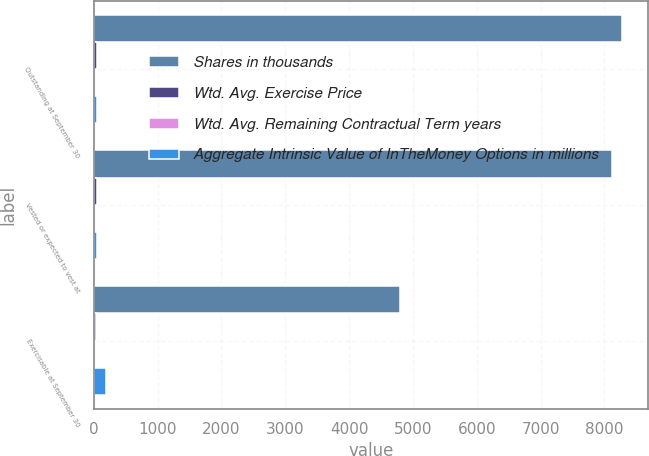<chart> <loc_0><loc_0><loc_500><loc_500><stacked_bar_chart><ecel><fcel>Outstanding at September 30<fcel>Vested or expected to vest at<fcel>Exercisable at September 30<nl><fcel>Shares in thousands<fcel>8268<fcel>8125<fcel>4794<nl><fcel>Wtd. Avg. Exercise Price<fcel>43.86<fcel>43.49<fcel>28.27<nl><fcel>Wtd. Avg. Remaining Contractual Term years<fcel>6.1<fcel>6.1<fcel>5.4<nl><fcel>Aggregate Intrinsic Value of InTheMoney Options in millions<fcel>51.6<fcel>51.6<fcel>197.7<nl></chart> 